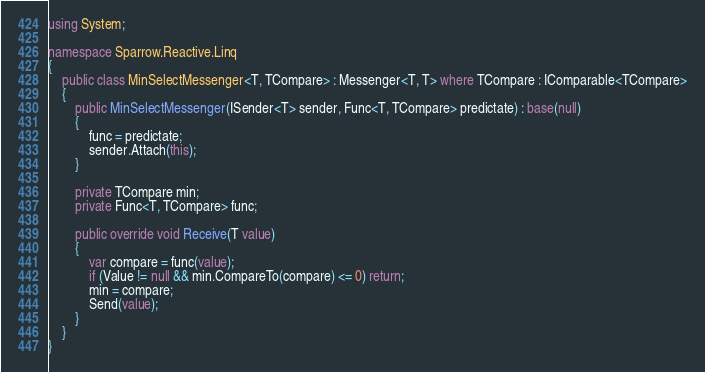<code> <loc_0><loc_0><loc_500><loc_500><_C#_>using System;

namespace Sparrow.Reactive.Linq
{
    public class MinSelectMessenger<T, TCompare> : Messenger<T, T> where TCompare : IComparable<TCompare>
    {
        public MinSelectMessenger(ISender<T> sender, Func<T, TCompare> predictate) : base(null)
        {
            func = predictate;
            sender.Attach(this);
        }
        
        private TCompare min;
        private Func<T, TCompare> func;

        public override void Receive(T value)
        {
            var compare = func(value);
            if (Value != null && min.CompareTo(compare) <= 0) return;
            min = compare;
            Send(value);
        }
    }
}</code> 